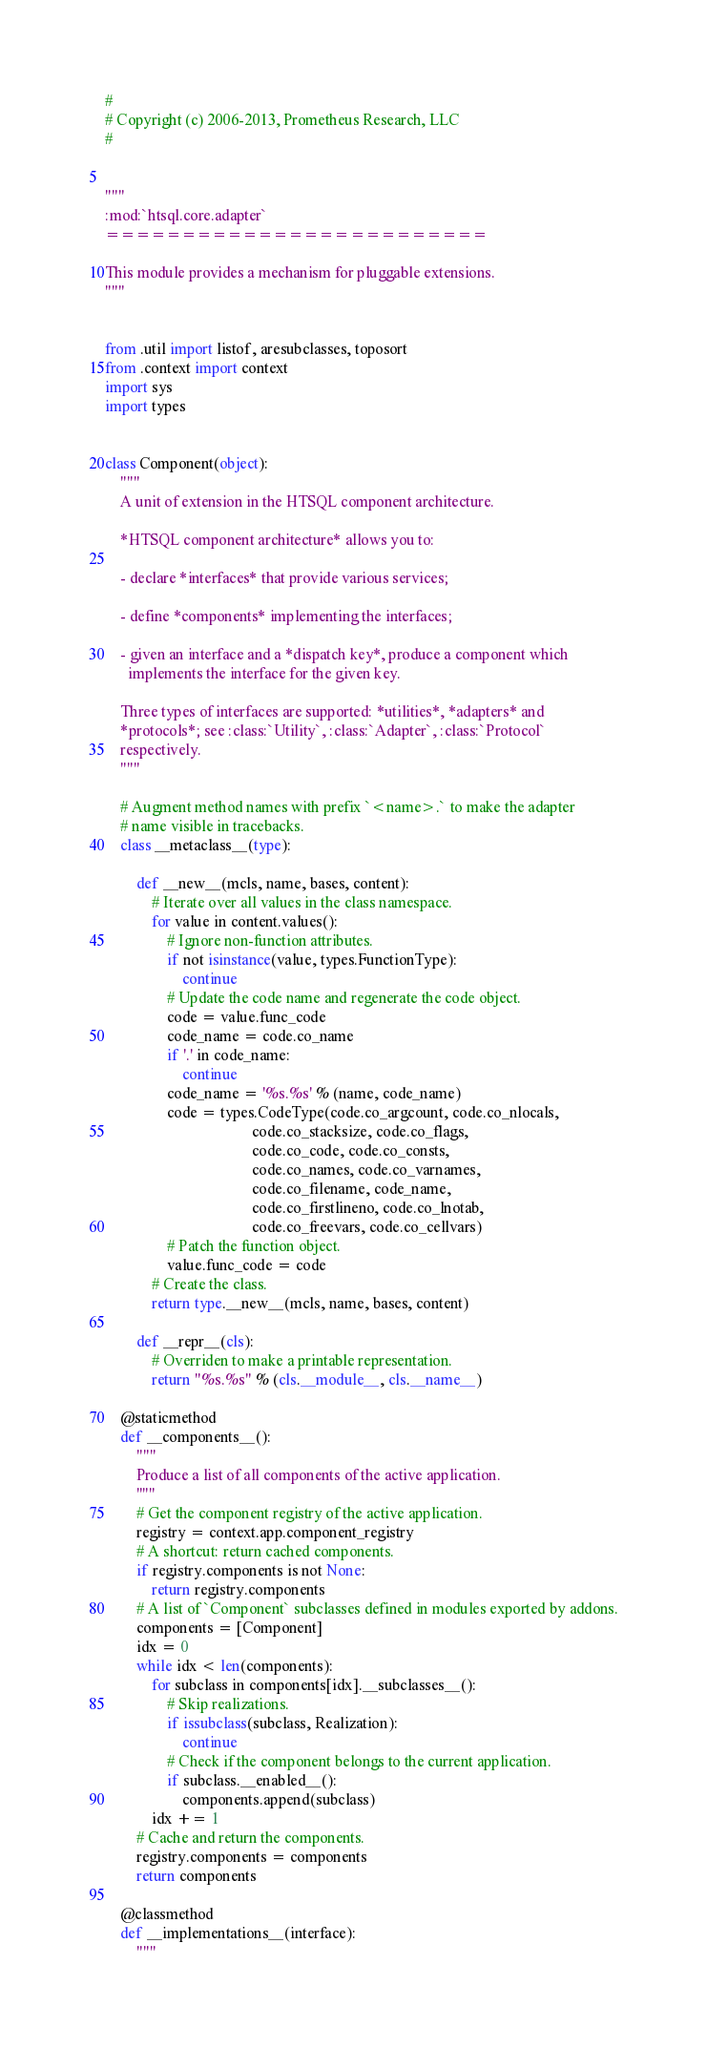<code> <loc_0><loc_0><loc_500><loc_500><_Python_>#
# Copyright (c) 2006-2013, Prometheus Research, LLC
#


"""
:mod:`htsql.core.adapter`
=========================

This module provides a mechanism for pluggable extensions.
"""


from .util import listof, aresubclasses, toposort
from .context import context
import sys
import types


class Component(object):
    """
    A unit of extension in the HTSQL component architecture.

    *HTSQL component architecture* allows you to:

    - declare *interfaces* that provide various services;

    - define *components* implementing the interfaces;

    - given an interface and a *dispatch key*, produce a component which
      implements the interface for the given key.

    Three types of interfaces are supported: *utilities*, *adapters* and
    *protocols*; see :class:`Utility`, :class:`Adapter`, :class:`Protocol`
    respectively.
    """

    # Augment method names with prefix `<name>.` to make the adapter
    # name visible in tracebacks.
    class __metaclass__(type):

        def __new__(mcls, name, bases, content):
            # Iterate over all values in the class namespace.
            for value in content.values():
                # Ignore non-function attributes.
                if not isinstance(value, types.FunctionType):
                    continue
                # Update the code name and regenerate the code object.
                code = value.func_code
                code_name = code.co_name
                if '.' in code_name:
                    continue
                code_name = '%s.%s' % (name, code_name)
                code = types.CodeType(code.co_argcount, code.co_nlocals,
                                      code.co_stacksize, code.co_flags,
                                      code.co_code, code.co_consts,
                                      code.co_names, code.co_varnames,
                                      code.co_filename, code_name,
                                      code.co_firstlineno, code.co_lnotab,
                                      code.co_freevars, code.co_cellvars)
                # Patch the function object.
                value.func_code = code
            # Create the class.
            return type.__new__(mcls, name, bases, content)

        def __repr__(cls):
            # Overriden to make a printable representation.
            return "%s.%s" % (cls.__module__, cls.__name__)

    @staticmethod
    def __components__():
        """
        Produce a list of all components of the active application.
        """
        # Get the component registry of the active application.
        registry = context.app.component_registry
        # A shortcut: return cached components.
        if registry.components is not None:
            return registry.components
        # A list of `Component` subclasses defined in modules exported by addons.
        components = [Component]
        idx = 0
        while idx < len(components):
            for subclass in components[idx].__subclasses__():
                # Skip realizations.
                if issubclass(subclass, Realization):
                    continue
                # Check if the component belongs to the current application.
                if subclass.__enabled__():
                    components.append(subclass)
            idx += 1
        # Cache and return the components.
        registry.components = components
        return components

    @classmethod
    def __implementations__(interface):
        """</code> 